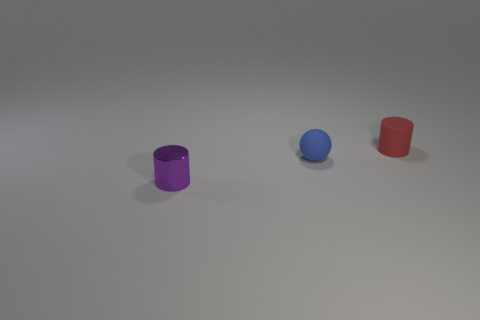What number of red rubber objects have the same shape as the small metal thing?
Give a very brief answer. 1. There is a tiny object behind the blue ball; is it the same shape as the tiny thing that is in front of the blue object?
Ensure brevity in your answer.  Yes. How many objects are matte things or objects that are behind the small purple thing?
Give a very brief answer. 2. What number of purple objects are the same size as the rubber cylinder?
Ensure brevity in your answer.  1. How many blue objects are small things or large matte objects?
Keep it short and to the point. 1. What is the shape of the tiny rubber thing on the left side of the matte object that is to the right of the ball?
Ensure brevity in your answer.  Sphere. There is another rubber object that is the same size as the blue thing; what shape is it?
Your answer should be very brief. Cylinder. Is there a small metal cylinder that has the same color as the sphere?
Provide a succinct answer. No. Are there an equal number of tiny purple metal cylinders right of the small purple cylinder and cylinders that are on the left side of the blue sphere?
Offer a very short reply. No. There is a small metal thing; does it have the same shape as the object behind the tiny blue ball?
Give a very brief answer. Yes. 